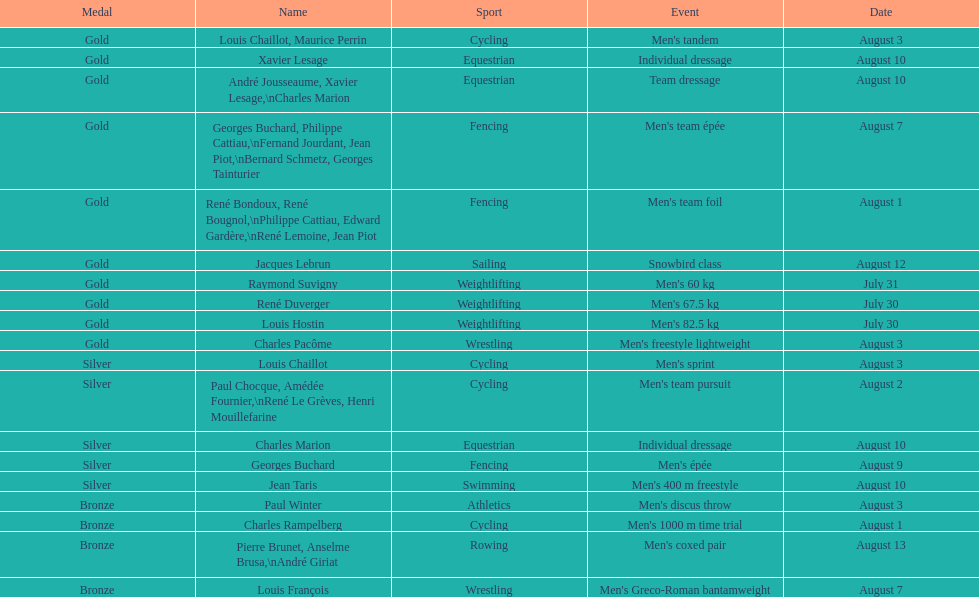How many medals were gained after august 3? 9. Write the full table. {'header': ['Medal', 'Name', 'Sport', 'Event', 'Date'], 'rows': [['Gold', 'Louis Chaillot, Maurice Perrin', 'Cycling', "Men's tandem", 'August 3'], ['Gold', 'Xavier Lesage', 'Equestrian', 'Individual dressage', 'August 10'], ['Gold', 'André Jousseaume, Xavier Lesage,\\nCharles Marion', 'Equestrian', 'Team dressage', 'August 10'], ['Gold', 'Georges Buchard, Philippe Cattiau,\\nFernand Jourdant, Jean Piot,\\nBernard Schmetz, Georges Tainturier', 'Fencing', "Men's team épée", 'August 7'], ['Gold', 'René Bondoux, René Bougnol,\\nPhilippe Cattiau, Edward Gardère,\\nRené Lemoine, Jean Piot', 'Fencing', "Men's team foil", 'August 1'], ['Gold', 'Jacques Lebrun', 'Sailing', 'Snowbird class', 'August 12'], ['Gold', 'Raymond Suvigny', 'Weightlifting', "Men's 60 kg", 'July 31'], ['Gold', 'René Duverger', 'Weightlifting', "Men's 67.5 kg", 'July 30'], ['Gold', 'Louis Hostin', 'Weightlifting', "Men's 82.5 kg", 'July 30'], ['Gold', 'Charles Pacôme', 'Wrestling', "Men's freestyle lightweight", 'August 3'], ['Silver', 'Louis Chaillot', 'Cycling', "Men's sprint", 'August 3'], ['Silver', 'Paul Chocque, Amédée Fournier,\\nRené Le Grèves, Henri Mouillefarine', 'Cycling', "Men's team pursuit", 'August 2'], ['Silver', 'Charles Marion', 'Equestrian', 'Individual dressage', 'August 10'], ['Silver', 'Georges Buchard', 'Fencing', "Men's épée", 'August 9'], ['Silver', 'Jean Taris', 'Swimming', "Men's 400 m freestyle", 'August 10'], ['Bronze', 'Paul Winter', 'Athletics', "Men's discus throw", 'August 3'], ['Bronze', 'Charles Rampelberg', 'Cycling', "Men's 1000 m time trial", 'August 1'], ['Bronze', 'Pierre Brunet, Anselme Brusa,\\nAndré Giriat', 'Rowing', "Men's coxed pair", 'August 13'], ['Bronze', 'Louis François', 'Wrestling', "Men's Greco-Roman bantamweight", 'August 7']]} 